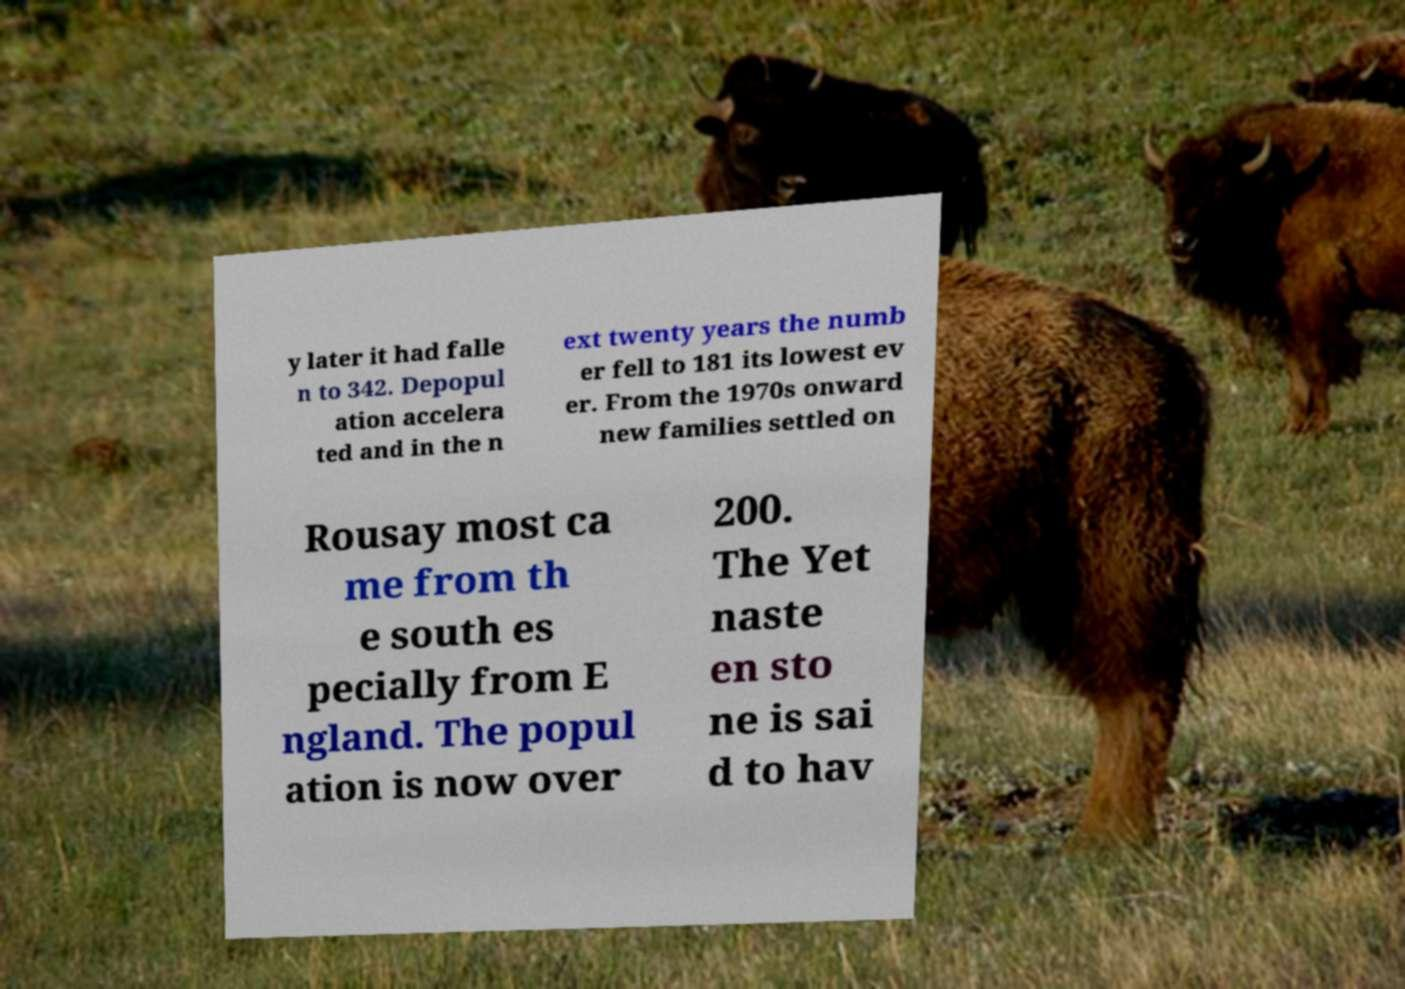Please read and relay the text visible in this image. What does it say? y later it had falle n to 342. Depopul ation accelera ted and in the n ext twenty years the numb er fell to 181 its lowest ev er. From the 1970s onward new families settled on Rousay most ca me from th e south es pecially from E ngland. The popul ation is now over 200. The Yet naste en sto ne is sai d to hav 